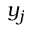<formula> <loc_0><loc_0><loc_500><loc_500>y _ { j }</formula> 